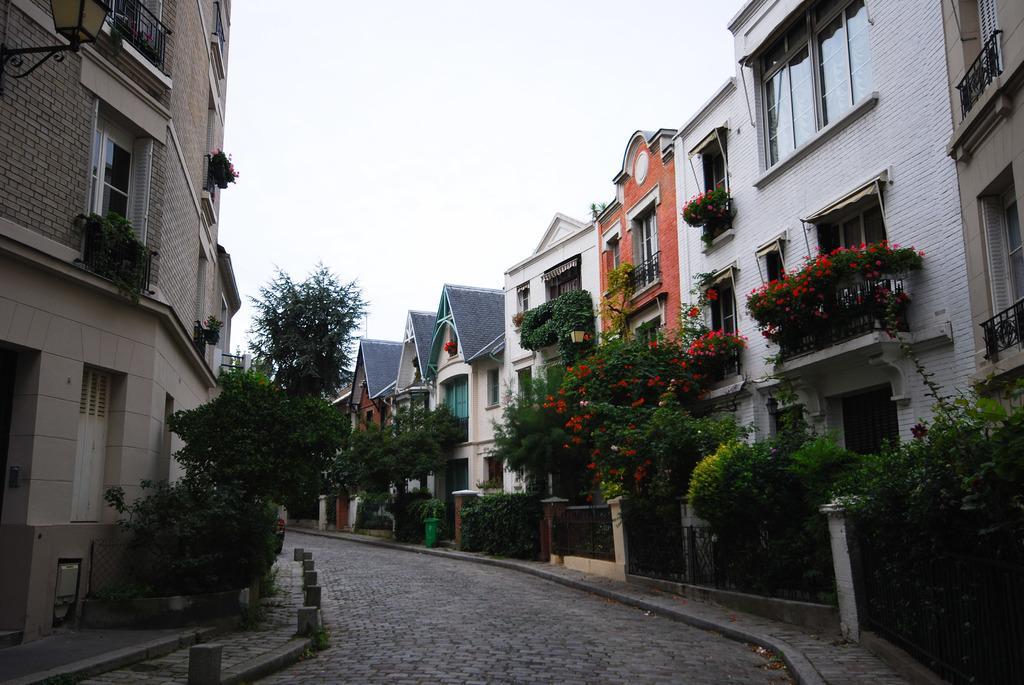In one or two sentences, can you explain what this image depicts? In this image there is a street lane. On both sides of it there is pavement having plants and trees. Background there are few buildings having plants in the balcony. Right side there is a building having few plants in the balcony. Plants are having flowers to it. Top of the image there is sky. 